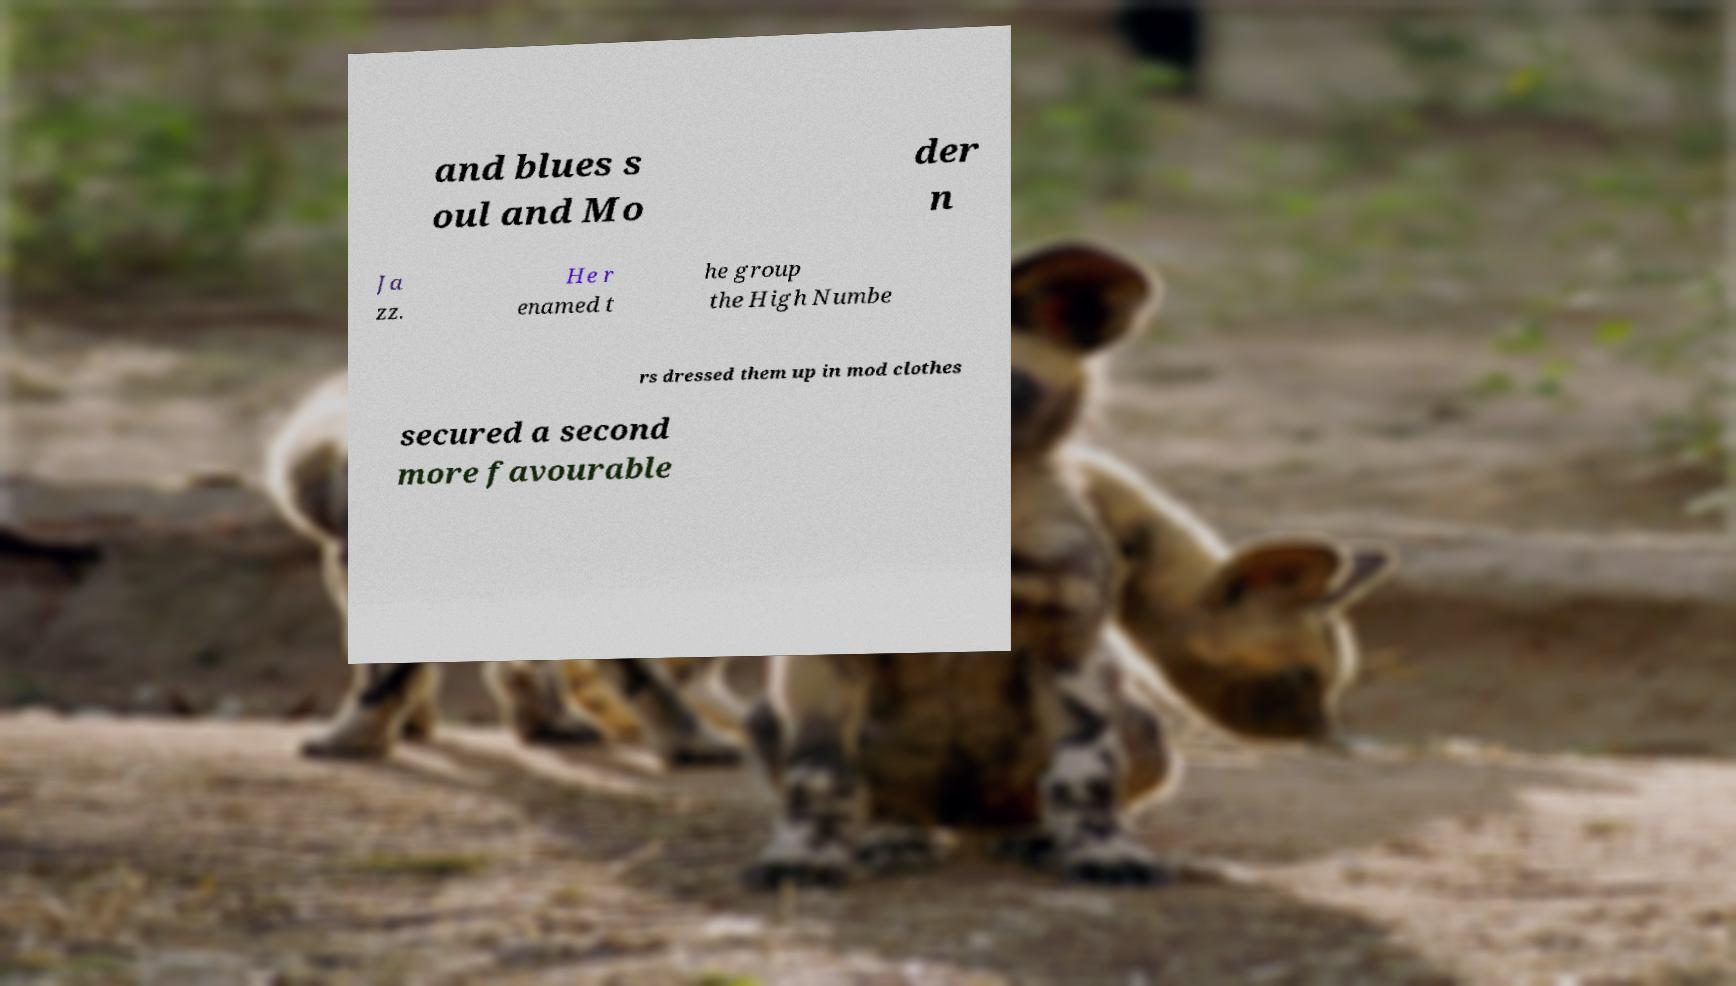I need the written content from this picture converted into text. Can you do that? and blues s oul and Mo der n Ja zz. He r enamed t he group the High Numbe rs dressed them up in mod clothes secured a second more favourable 